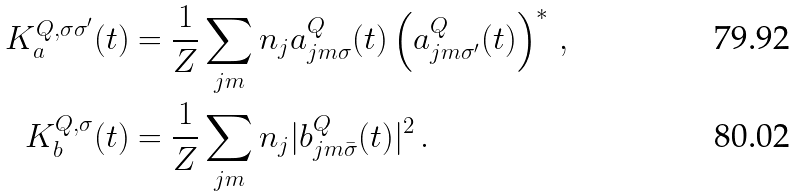<formula> <loc_0><loc_0><loc_500><loc_500>K _ { a } ^ { Q , \sigma \sigma ^ { \prime } } ( t ) & = \frac { 1 } { Z } \sum _ { j m } n _ { j } a ^ { Q } _ { j m \sigma } ( t ) \left ( a ^ { Q } _ { j m \sigma ^ { \prime } } ( t ) \right ) ^ { * } \, , \\ K _ { b } ^ { Q , \sigma } ( t ) & = \frac { 1 } { Z } \sum _ { j m } n _ { j } | b ^ { Q } _ { j m \bar { \sigma } } ( t ) | ^ { 2 } \, .</formula> 